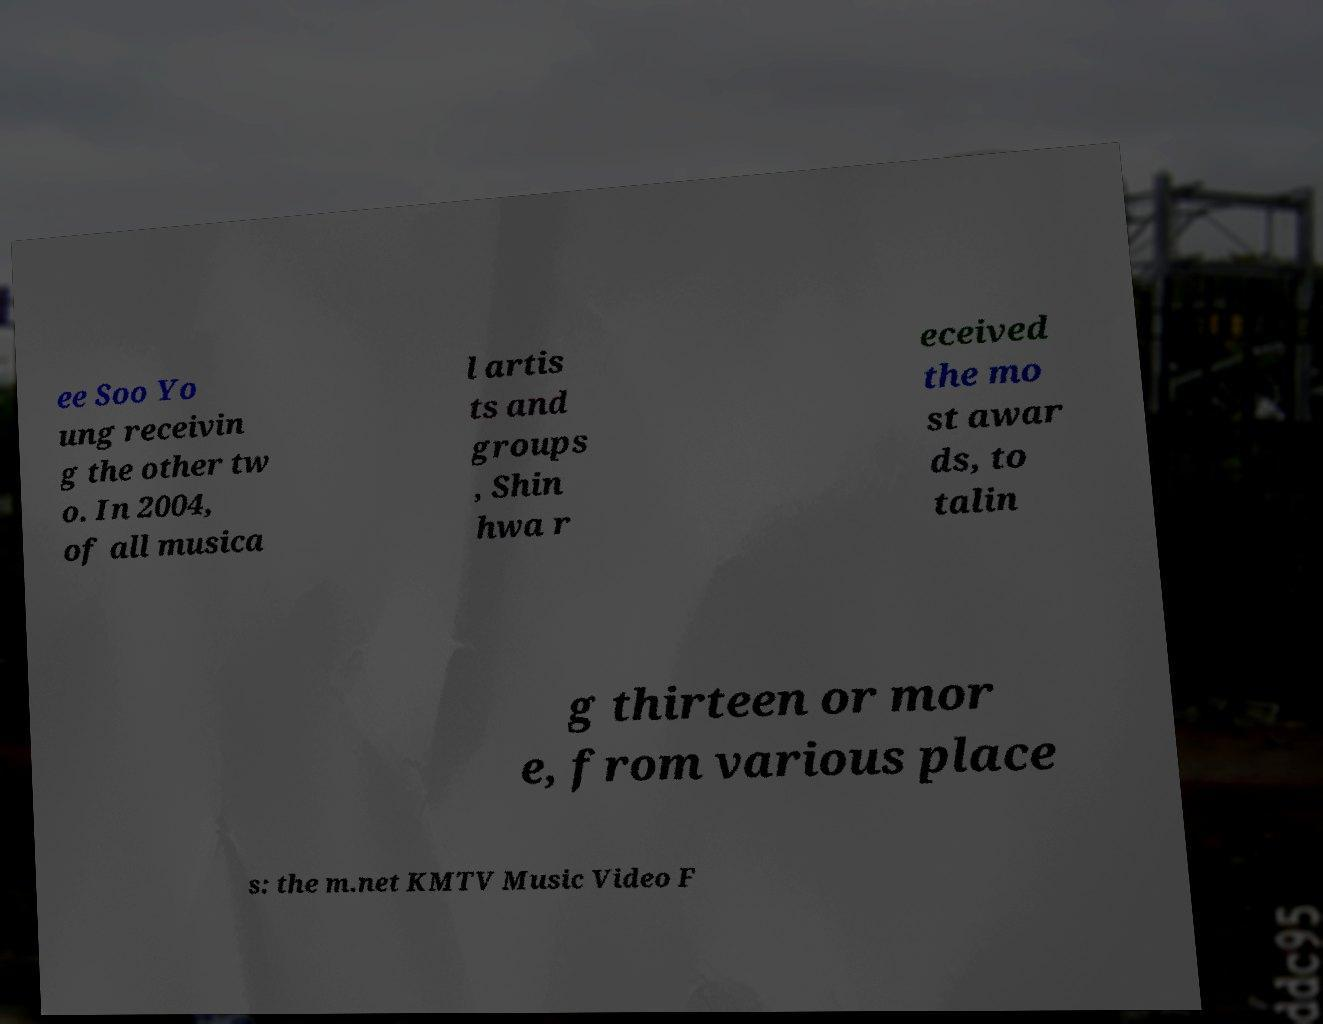There's text embedded in this image that I need extracted. Can you transcribe it verbatim? ee Soo Yo ung receivin g the other tw o. In 2004, of all musica l artis ts and groups , Shin hwa r eceived the mo st awar ds, to talin g thirteen or mor e, from various place s: the m.net KMTV Music Video F 